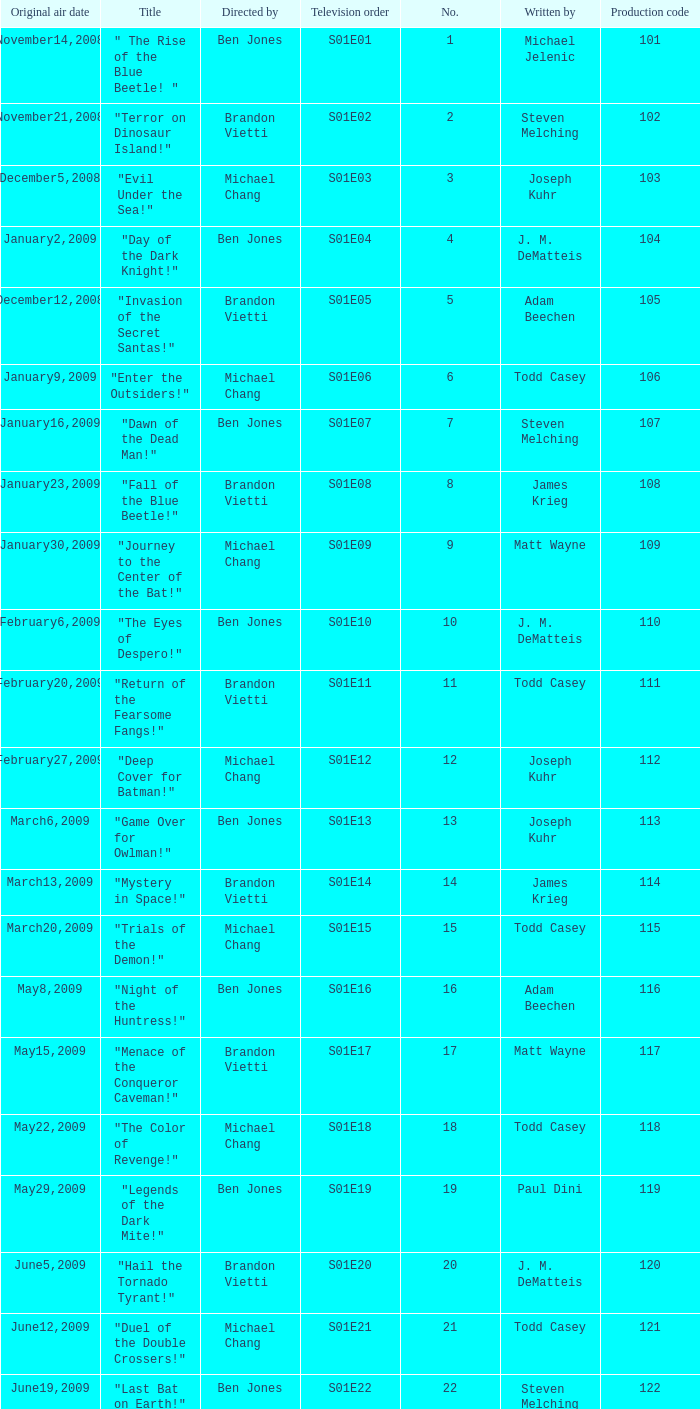What is the television order of the episode directed by ben jones, written by j. m. dematteis and originally aired on february6,2009 S01E10. 